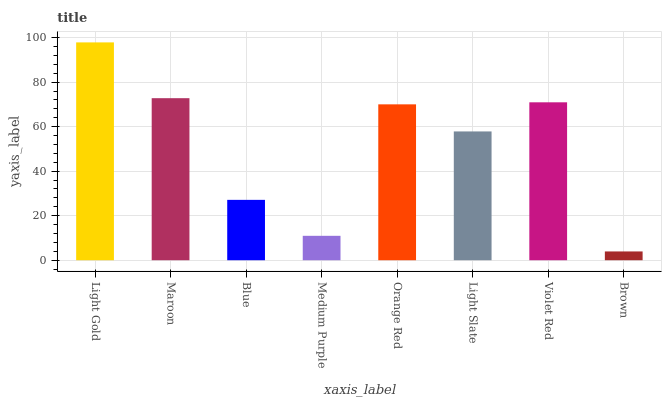Is Maroon the minimum?
Answer yes or no. No. Is Maroon the maximum?
Answer yes or no. No. Is Light Gold greater than Maroon?
Answer yes or no. Yes. Is Maroon less than Light Gold?
Answer yes or no. Yes. Is Maroon greater than Light Gold?
Answer yes or no. No. Is Light Gold less than Maroon?
Answer yes or no. No. Is Orange Red the high median?
Answer yes or no. Yes. Is Light Slate the low median?
Answer yes or no. Yes. Is Medium Purple the high median?
Answer yes or no. No. Is Medium Purple the low median?
Answer yes or no. No. 